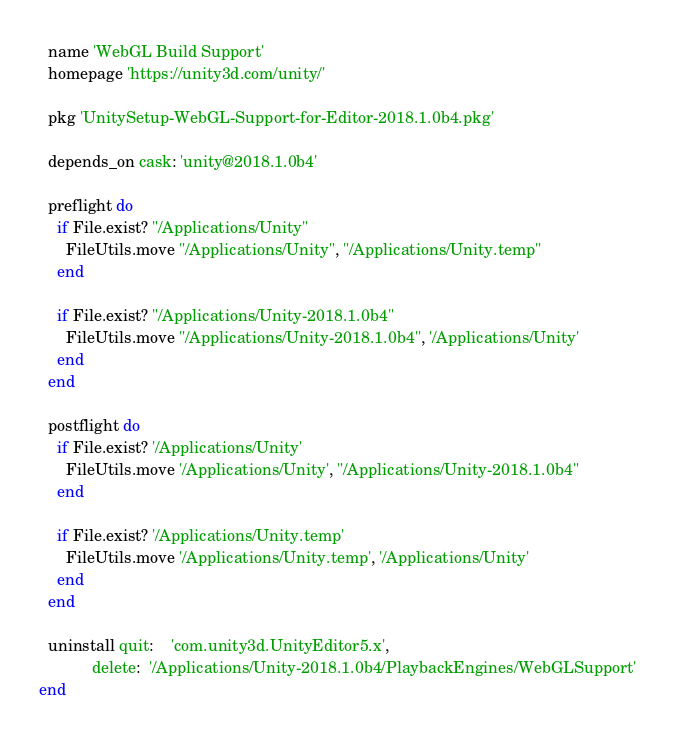Convert code to text. <code><loc_0><loc_0><loc_500><loc_500><_Ruby_>  name 'WebGL Build Support'
  homepage 'https://unity3d.com/unity/'

  pkg 'UnitySetup-WebGL-Support-for-Editor-2018.1.0b4.pkg'

  depends_on cask: 'unity@2018.1.0b4'

  preflight do
    if File.exist? "/Applications/Unity"
      FileUtils.move "/Applications/Unity", "/Applications/Unity.temp"
    end

    if File.exist? "/Applications/Unity-2018.1.0b4"
      FileUtils.move "/Applications/Unity-2018.1.0b4", '/Applications/Unity'
    end
  end

  postflight do
    if File.exist? '/Applications/Unity'
      FileUtils.move '/Applications/Unity', "/Applications/Unity-2018.1.0b4"
    end

    if File.exist? '/Applications/Unity.temp'
      FileUtils.move '/Applications/Unity.temp', '/Applications/Unity'
    end
  end

  uninstall quit:    'com.unity3d.UnityEditor5.x',
            delete:  '/Applications/Unity-2018.1.0b4/PlaybackEngines/WebGLSupport'
end
</code> 